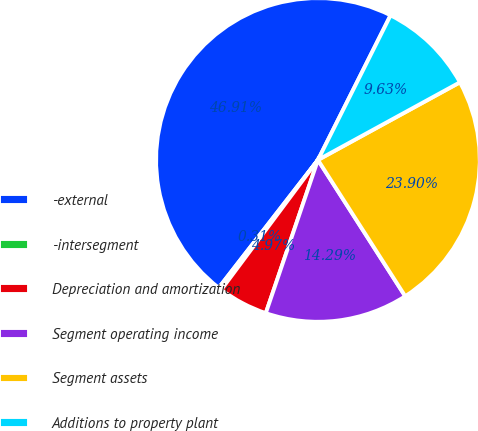Convert chart. <chart><loc_0><loc_0><loc_500><loc_500><pie_chart><fcel>-external<fcel>-intersegment<fcel>Depreciation and amortization<fcel>Segment operating income<fcel>Segment assets<fcel>Additions to property plant<nl><fcel>46.91%<fcel>0.31%<fcel>4.97%<fcel>14.29%<fcel>23.9%<fcel>9.63%<nl></chart> 